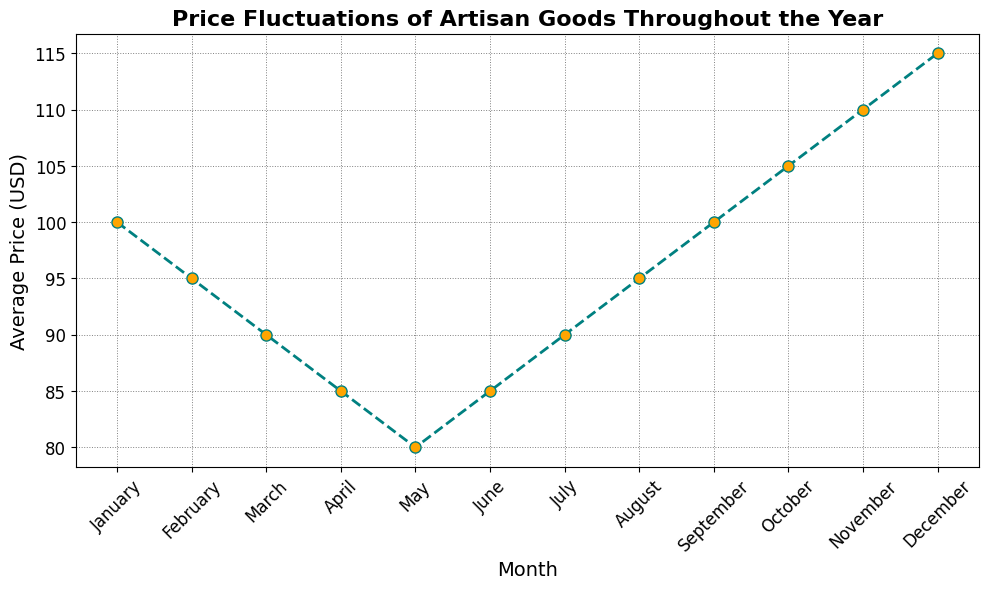What is the lowest average price throughout the year? The chart shows the average prices for each month. By examining the values, the lowest average price is in May.
Answer: 80 In which months does the average price increase after a decrease? From March to May, the price decreases from 90 to 80. Then, from May to June, the price increases from 80 to 85.
Answer: June Which month has the highest average price? The highest point on the chart represents the peak price. December has the highest average price at 115 USD.
Answer: December What is the difference in average price between the highest and lowest months? The highest price is 115 USD (December) and the lowest is 80 USD (May). The difference is calculated as 115 - 80.
Answer: 35 Between which two consecutive months is the most significant price drop observed? By comparing the month-to-month changes in the chart, the most significant drop is between January and February, where the price drops from 100 to 95.
Answer: January and February What is the average price in the first half of the year (January to June)? Add the average prices from January to June: 100 + 95 + 90 + 85 + 80 + 85 = 535, then divide by 6 (the number of months). 535/6 = 89.17 USD.
Answer: 89.17 During which period does the price consistently increase without a drop? From May to December, the price consistently increases each month.
Answer: May to December How much does the price change from the beginning to the end of the year? The price in January is 100 USD, and in December, it is 115 USD. The change is 115 - 100.
Answer: 15 Is there any month where the average price remains the same as the previous month? By inspecting the chart, we notice that there is no month where the average price remains the same as the previous month; all values change.
Answer: No How many months have average prices above 100 USD? By examining the chart, we find that the months with prices above 100 USD are October, November, and December.
Answer: 3 